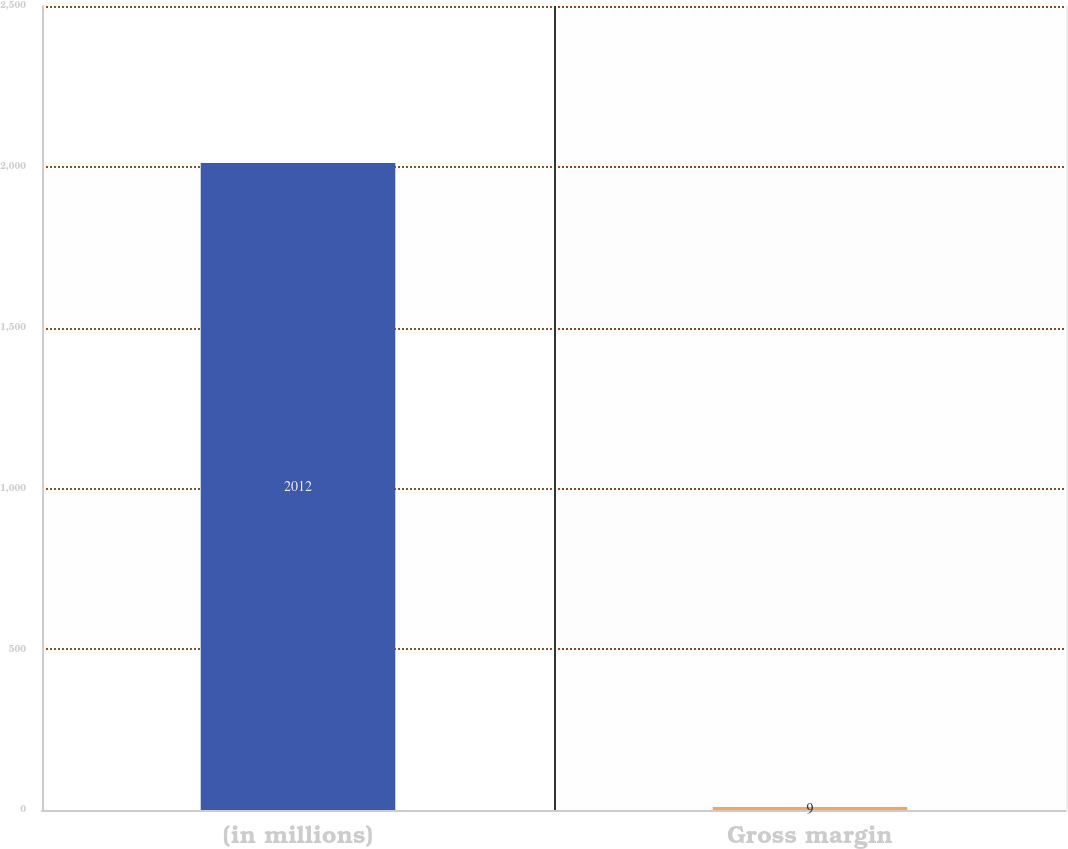Convert chart to OTSL. <chart><loc_0><loc_0><loc_500><loc_500><bar_chart><fcel>(in millions)<fcel>Gross margin<nl><fcel>2012<fcel>9<nl></chart> 